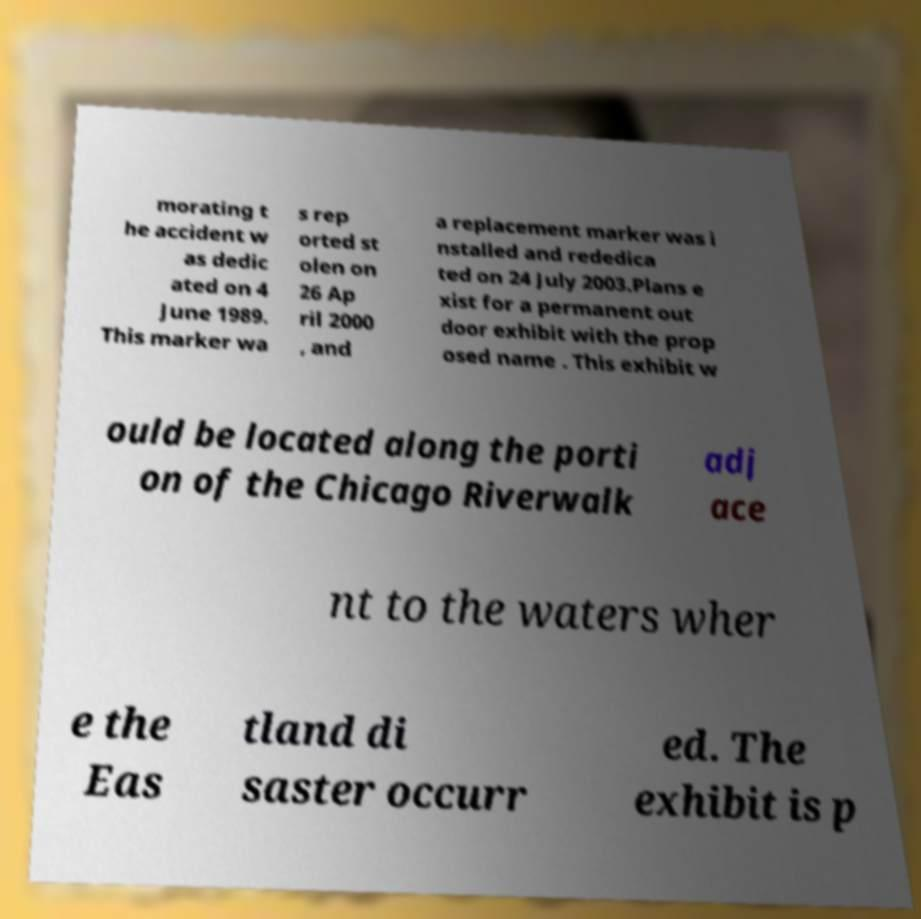Can you read and provide the text displayed in the image?This photo seems to have some interesting text. Can you extract and type it out for me? morating t he accident w as dedic ated on 4 June 1989. This marker wa s rep orted st olen on 26 Ap ril 2000 , and a replacement marker was i nstalled and rededica ted on 24 July 2003.Plans e xist for a permanent out door exhibit with the prop osed name . This exhibit w ould be located along the porti on of the Chicago Riverwalk adj ace nt to the waters wher e the Eas tland di saster occurr ed. The exhibit is p 